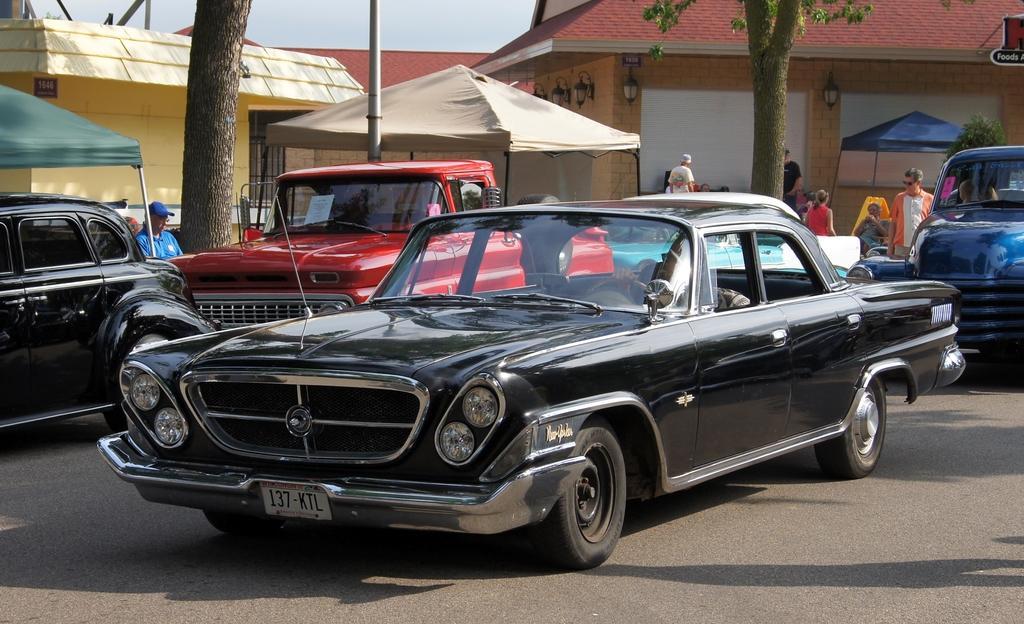Can you describe this image briefly? In this image, there are five cars on the road. These are the canopy tents. I can see few people standing and few people sitting. This looks like a tree trunk. These are the trees. I think these are the houses. I can see the lamps attached to the wall. 